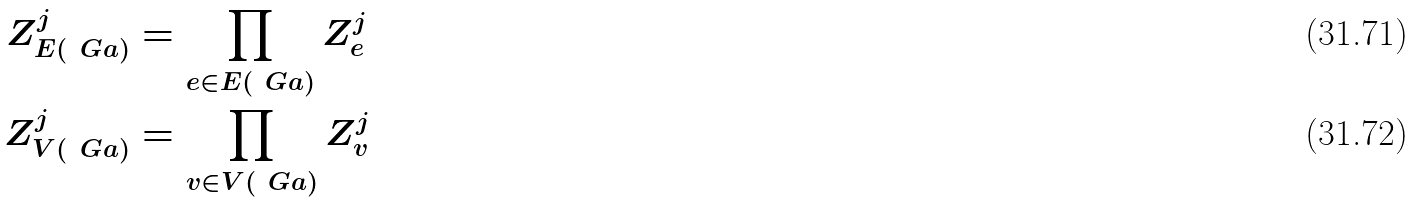Convert formula to latex. <formula><loc_0><loc_0><loc_500><loc_500>Z _ { E ( \ G a ) } ^ { j } & = \prod _ { e \in E ( \ G a ) } Z _ { e } ^ { j } \\ Z _ { V ( \ G a ) } ^ { j } & = \prod _ { v \in V ( \ G a ) } Z _ { v } ^ { j }</formula> 